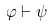<formula> <loc_0><loc_0><loc_500><loc_500>\varphi \vdash \psi</formula> 